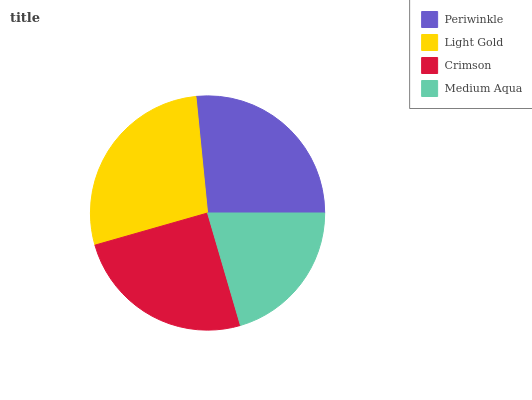Is Medium Aqua the minimum?
Answer yes or no. Yes. Is Light Gold the maximum?
Answer yes or no. Yes. Is Crimson the minimum?
Answer yes or no. No. Is Crimson the maximum?
Answer yes or no. No. Is Light Gold greater than Crimson?
Answer yes or no. Yes. Is Crimson less than Light Gold?
Answer yes or no. Yes. Is Crimson greater than Light Gold?
Answer yes or no. No. Is Light Gold less than Crimson?
Answer yes or no. No. Is Periwinkle the high median?
Answer yes or no. Yes. Is Crimson the low median?
Answer yes or no. Yes. Is Medium Aqua the high median?
Answer yes or no. No. Is Periwinkle the low median?
Answer yes or no. No. 